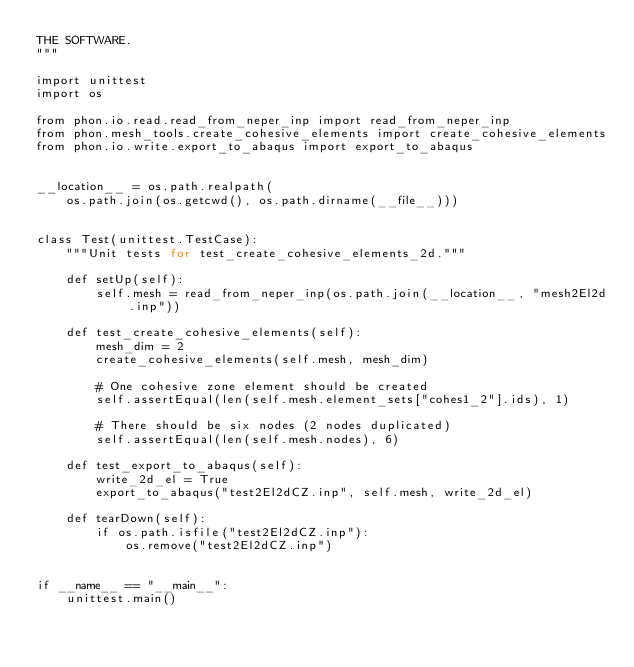Convert code to text. <code><loc_0><loc_0><loc_500><loc_500><_Python_>THE SOFTWARE.
"""

import unittest
import os

from phon.io.read.read_from_neper_inp import read_from_neper_inp
from phon.mesh_tools.create_cohesive_elements import create_cohesive_elements
from phon.io.write.export_to_abaqus import export_to_abaqus


__location__ = os.path.realpath(
    os.path.join(os.getcwd(), os.path.dirname(__file__)))


class Test(unittest.TestCase):
    """Unit tests for test_create_cohesive_elements_2d."""

    def setUp(self):
        self.mesh = read_from_neper_inp(os.path.join(__location__, "mesh2El2d.inp"))

    def test_create_cohesive_elements(self):
        mesh_dim = 2
        create_cohesive_elements(self.mesh, mesh_dim)

        # One cohesive zone element should be created
        self.assertEqual(len(self.mesh.element_sets["cohes1_2"].ids), 1)

        # There should be six nodes (2 nodes duplicated)
        self.assertEqual(len(self.mesh.nodes), 6)

    def test_export_to_abaqus(self):
        write_2d_el = True
        export_to_abaqus("test2El2dCZ.inp", self.mesh, write_2d_el)

    def tearDown(self):
        if os.path.isfile("test2El2dCZ.inp"):
            os.remove("test2El2dCZ.inp")


if __name__ == "__main__":
    unittest.main()

</code> 